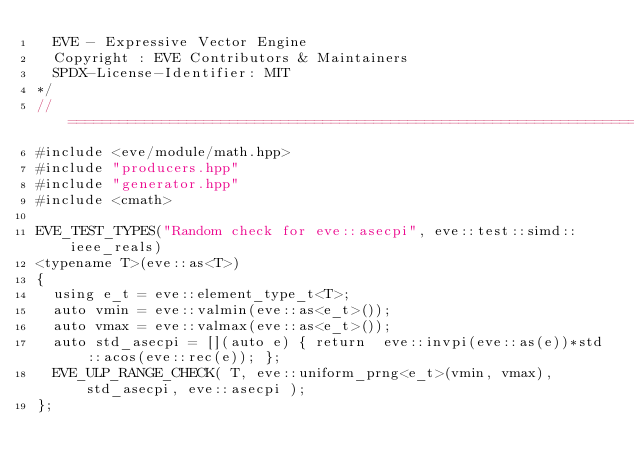<code> <loc_0><loc_0><loc_500><loc_500><_C++_>  EVE - Expressive Vector Engine
  Copyright : EVE Contributors & Maintainers
  SPDX-License-Identifier: MIT
*/
//==================================================================================================
#include <eve/module/math.hpp>
#include "producers.hpp"
#include "generator.hpp"
#include <cmath>

EVE_TEST_TYPES("Random check for eve::asecpi", eve::test::simd::ieee_reals)
<typename T>(eve::as<T>)
{
  using e_t = eve::element_type_t<T>;
  auto vmin = eve::valmin(eve::as<e_t>());
  auto vmax = eve::valmax(eve::as<e_t>());
  auto std_asecpi = [](auto e) { return  eve::invpi(eve::as(e))*std::acos(eve::rec(e)); };
  EVE_ULP_RANGE_CHECK( T, eve::uniform_prng<e_t>(vmin, vmax),  std_asecpi, eve::asecpi );
};
</code> 